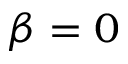<formula> <loc_0><loc_0><loc_500><loc_500>\beta = 0</formula> 